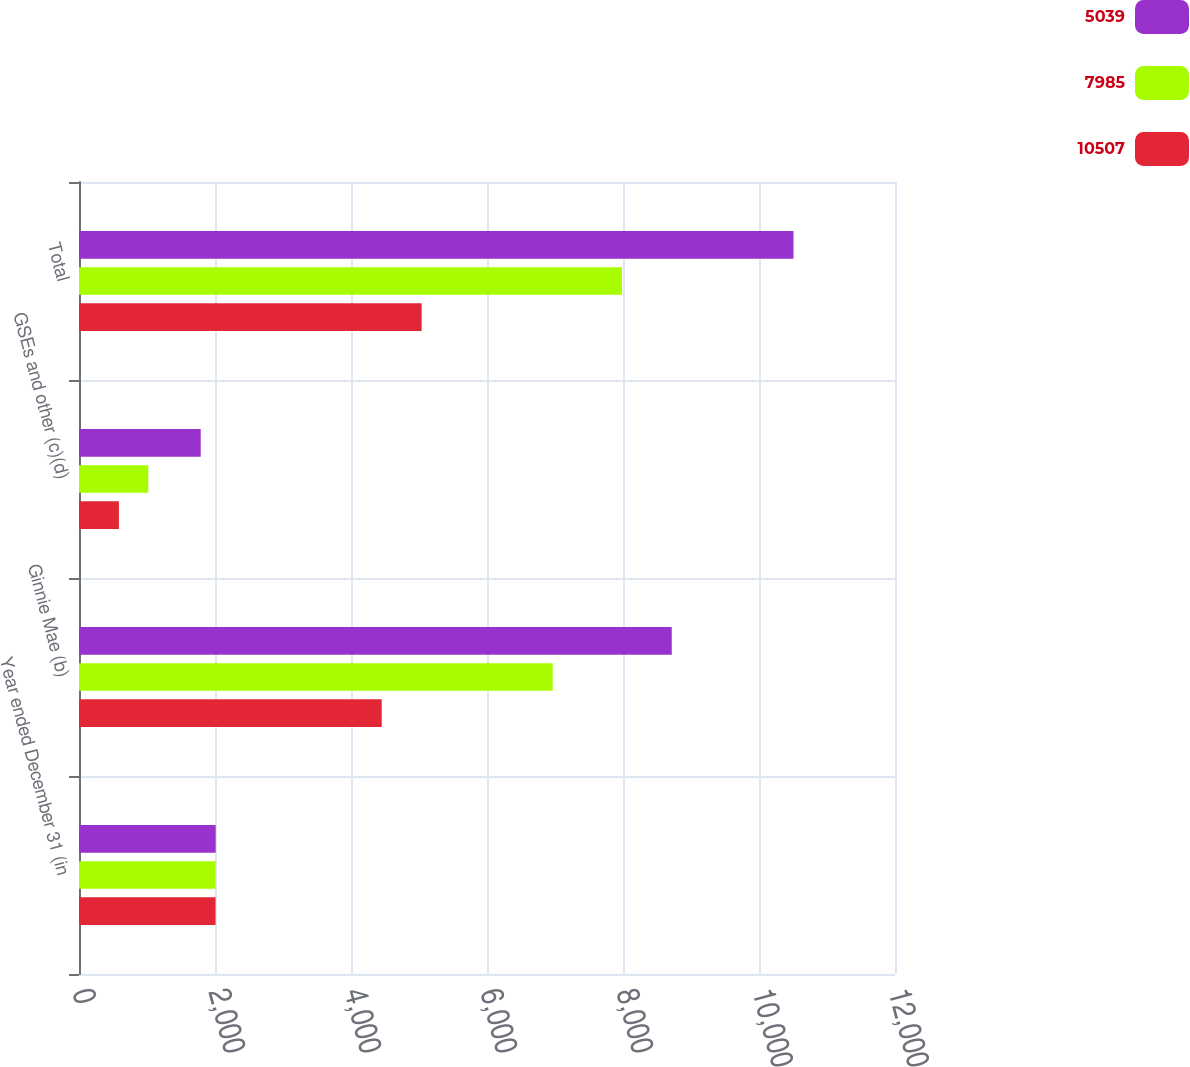Convert chart. <chart><loc_0><loc_0><loc_500><loc_500><stacked_bar_chart><ecel><fcel>Year ended December 31 (in<fcel>Ginnie Mae (b)<fcel>GSEs and other (c)(d)<fcel>Total<nl><fcel>5039<fcel>2010<fcel>8717<fcel>1790<fcel>10507<nl><fcel>7985<fcel>2009<fcel>6966<fcel>1019<fcel>7985<nl><fcel>10507<fcel>2008<fcel>4452<fcel>587<fcel>5039<nl></chart> 